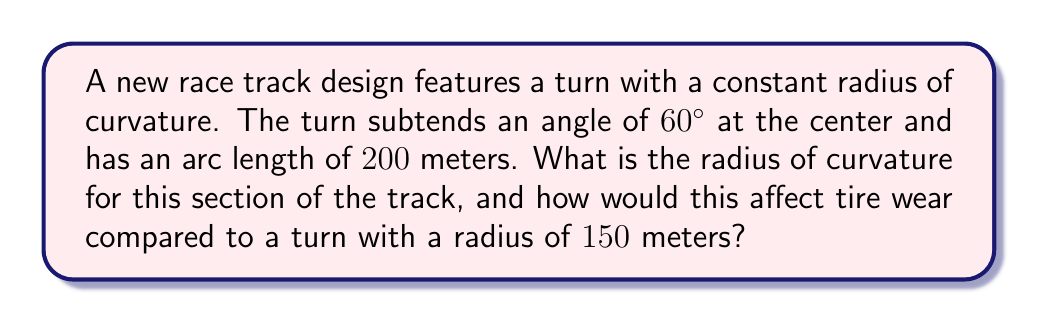Solve this math problem. Let's approach this step-by-step:

1) The formula for arc length ($s$) is:
   $$s = r\theta$$
   where $r$ is the radius and $\theta$ is the angle in radians.

2) We're given the arc length ($s = 200$ m) and the angle in degrees ($60°$).

3) First, we need to convert $60°$ to radians:
   $$\theta = 60° \cdot \frac{\pi}{180°} = \frac{\pi}{3} \text{ radians}$$

4) Now we can substitute these values into the arc length formula:
   $$200 = r \cdot \frac{\pi}{3}$$

5) Solving for $r$:
   $$r = \frac{200}{\pi/3} = \frac{600}{\pi} \approx 190.99 \text{ meters}$$

6) Comparing to a turn with a 150-meter radius:
   - The larger radius (191 m vs 150 m) means a gentler curve.
   - Gentler curves generally result in less tire wear due to reduced lateral forces.
   - The difference in radius is about 27% larger, which could significantly reduce tire wear in this section.

[asy]
import geometry;

pair O=(0,0);
real r=5;
path c=Circle(O,r);
draw(c);
draw(O--(-r,0),dashed);
draw(O--(r*cos(pi/3),r*sin(pi/3)),dashed);
draw(arc(O,r,0,60),linewidth(2));
label("60°",O+(r/2,r/4),NE);
label("r",O+(r/2,-r/4),S);
[/asy]
Answer: Radius of curvature: $\frac{600}{\pi} \approx 190.99$ meters. Larger radius reduces tire wear compared to 150-meter turn. 